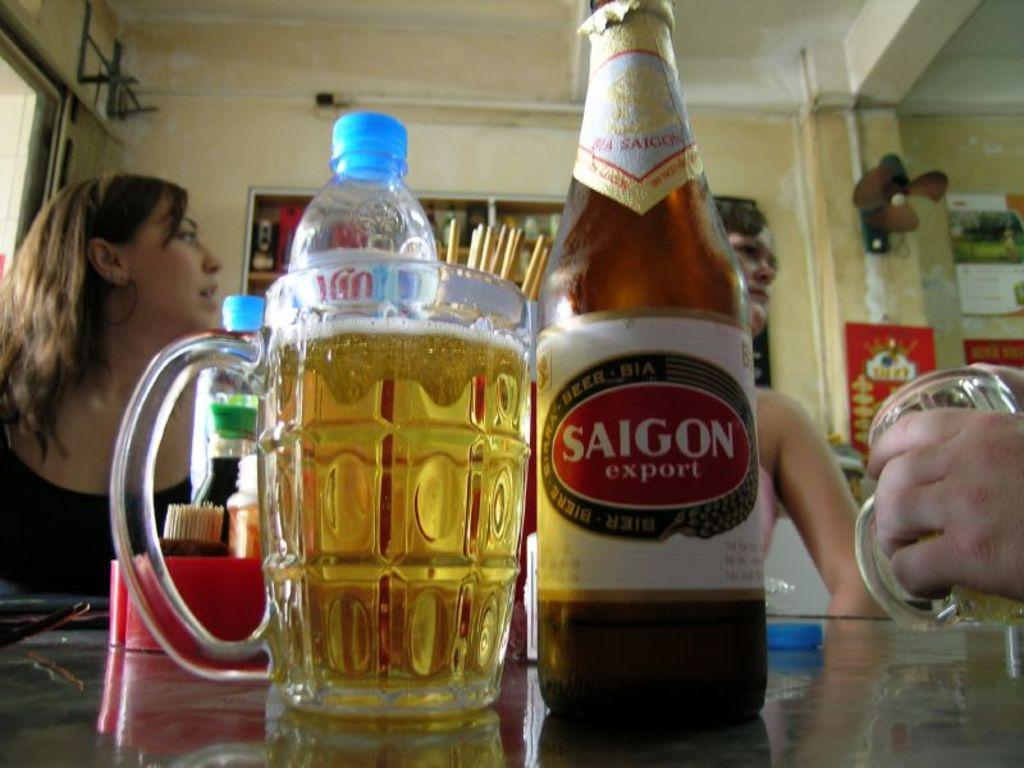What is one of the objects visible in the image? There is a jug in the image. What other object can be seen in the image? There is a beer bottle in the image. How many people are present in the image? There are two girls sitting in the image. Where is the bomb hidden in the image? There is no bomb present in the image. Is the prison visible in the image? There is no prison present in the image. 